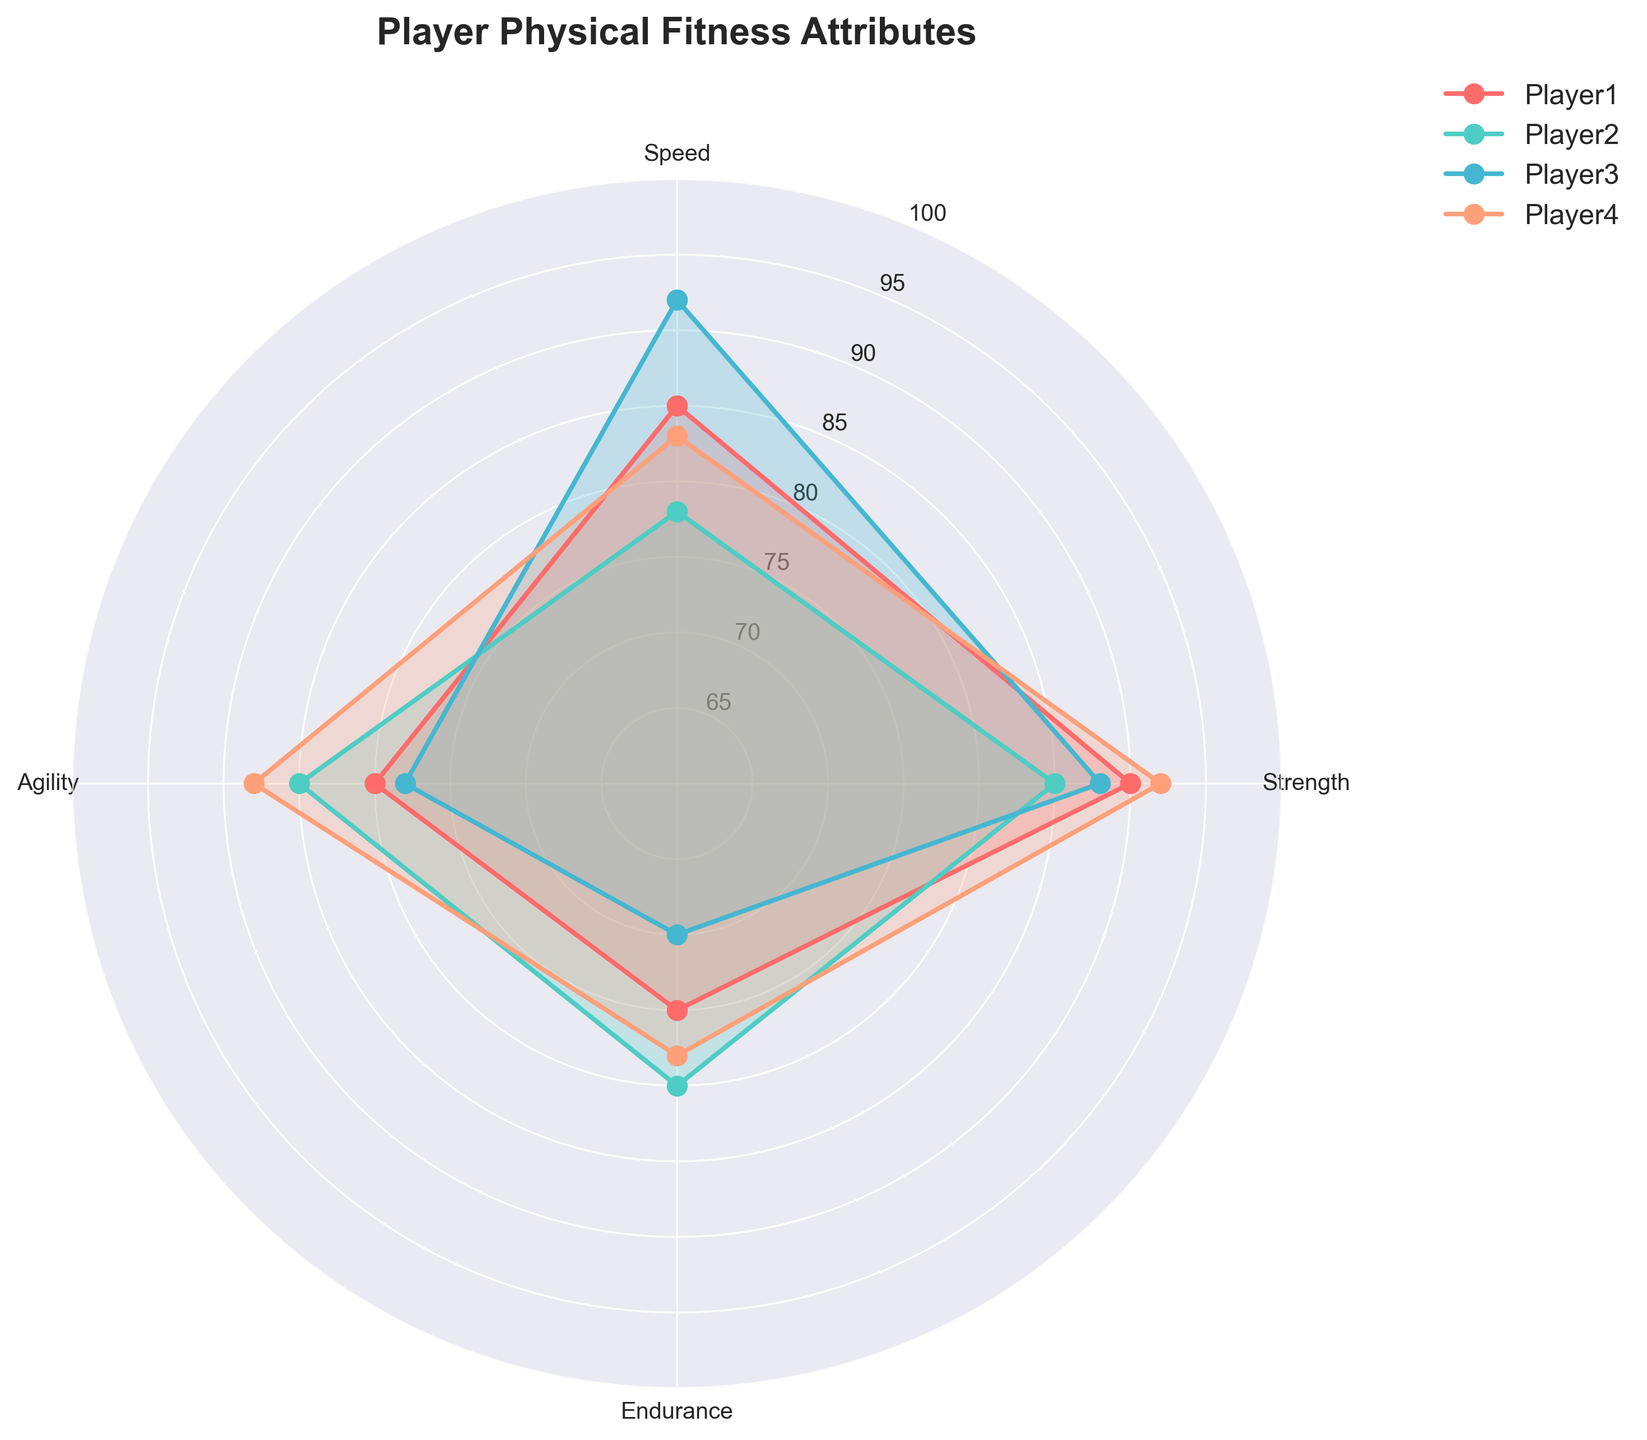What is the title of the radar chart? The title can be directly seen at the top of the chart.
Answer: Player Physical Fitness Attributes What are the four fitness attributes displayed on the radar chart? The four fitness attributes are displayed at the angles of the radar chart and can be read from the labels on the chart.
Answer: Speed, Strength, Endurance, Agility Which player has the highest speed? By examining the plots for Speed, you can see that Player3 has the highest value reaching up to 92.
Answer: Player3 Who has the lowest endurance value among the players? Among the players, Player3 shows the lowest endurance value which is at 70.
Answer: Player3 Compare the agility of Player2 and Player4; who has more agility? From the radar chart, we observe Player4's agility value is at 88, while Player2's agility is at 85.
Answer: Player4 Which player exhibits the most balanced fitness attributes across all four categories? By observing the shape and area covered by each player's radar, Player2 appears the most balanced across all attributes with less extreme highs and lows.
Answer: Player2 If you average the values of strength and agility for Player1, what is the result? Player1's strength is 90 and agility is 80: (90 + 80) / 2 = 85.
Answer: 85 Between Speed and Endurance, which attribute shows the higher average value across all players? Calculate average speed: (85 + 78 + 92 + 83)/4 = 84.5. Calculate average endurance: (75 + 80 + 70 + 78)/4 = 75.75. Compare these values.
Answer: Speed Among all players, who demonstrates the largest difference between strength and endurance? For each player, calculate the absolute difference between strength and endurance and compare: Player1 = 15, Player2 = 5, Player3 = 18, Player4 = 14. The largest difference is for Player3.
Answer: Player3 